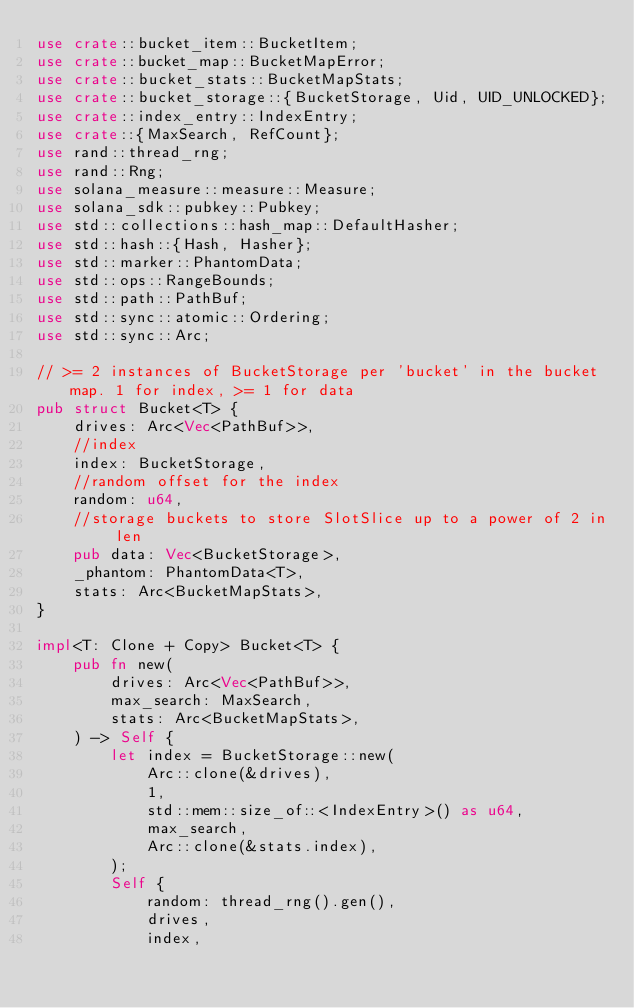Convert code to text. <code><loc_0><loc_0><loc_500><loc_500><_Rust_>use crate::bucket_item::BucketItem;
use crate::bucket_map::BucketMapError;
use crate::bucket_stats::BucketMapStats;
use crate::bucket_storage::{BucketStorage, Uid, UID_UNLOCKED};
use crate::index_entry::IndexEntry;
use crate::{MaxSearch, RefCount};
use rand::thread_rng;
use rand::Rng;
use solana_measure::measure::Measure;
use solana_sdk::pubkey::Pubkey;
use std::collections::hash_map::DefaultHasher;
use std::hash::{Hash, Hasher};
use std::marker::PhantomData;
use std::ops::RangeBounds;
use std::path::PathBuf;
use std::sync::atomic::Ordering;
use std::sync::Arc;

// >= 2 instances of BucketStorage per 'bucket' in the bucket map. 1 for index, >= 1 for data
pub struct Bucket<T> {
    drives: Arc<Vec<PathBuf>>,
    //index
    index: BucketStorage,
    //random offset for the index
    random: u64,
    //storage buckets to store SlotSlice up to a power of 2 in len
    pub data: Vec<BucketStorage>,
    _phantom: PhantomData<T>,
    stats: Arc<BucketMapStats>,
}

impl<T: Clone + Copy> Bucket<T> {
    pub fn new(
        drives: Arc<Vec<PathBuf>>,
        max_search: MaxSearch,
        stats: Arc<BucketMapStats>,
    ) -> Self {
        let index = BucketStorage::new(
            Arc::clone(&drives),
            1,
            std::mem::size_of::<IndexEntry>() as u64,
            max_search,
            Arc::clone(&stats.index),
        );
        Self {
            random: thread_rng().gen(),
            drives,
            index,</code> 